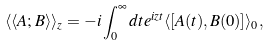Convert formula to latex. <formula><loc_0><loc_0><loc_500><loc_500>\langle \langle A ; B \rangle \rangle _ { z } = - i \int _ { 0 } ^ { \infty } d t e ^ { i z t } \langle [ A ( t ) , B ( 0 ) ] \rangle _ { 0 } ,</formula> 